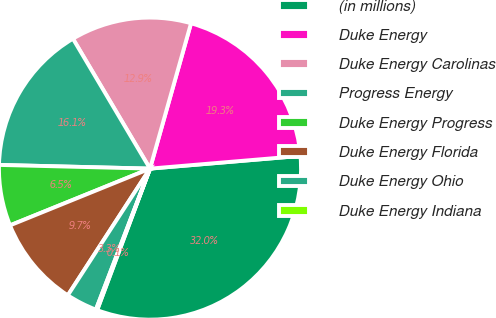<chart> <loc_0><loc_0><loc_500><loc_500><pie_chart><fcel>(in millions)<fcel>Duke Energy<fcel>Duke Energy Carolinas<fcel>Progress Energy<fcel>Duke Energy Progress<fcel>Duke Energy Florida<fcel>Duke Energy Ohio<fcel>Duke Energy Indiana<nl><fcel>32.03%<fcel>19.28%<fcel>12.9%<fcel>16.09%<fcel>6.52%<fcel>9.71%<fcel>3.33%<fcel>0.14%<nl></chart> 